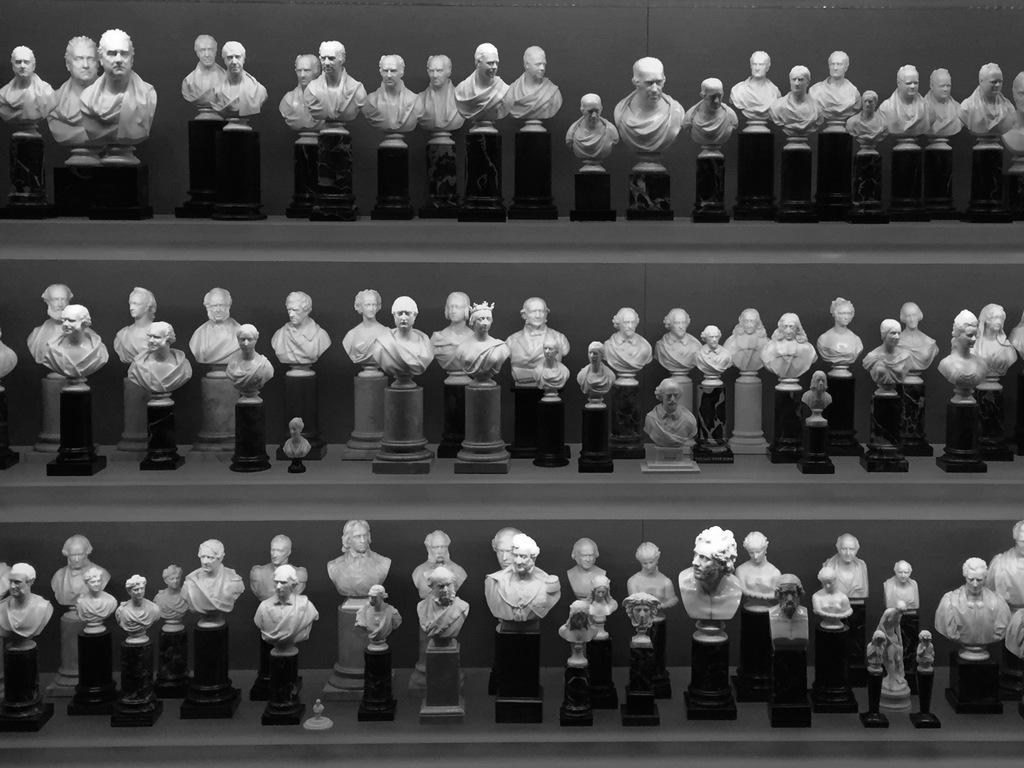What can be seen in the image? There is a display rack in the image. What is on the display rack? The display rack contains figurines. What type of tin is used to make the figurines in the image? There is no mention of tin or any specific material used to make the figurines in the image. The figurines are simply described as being on the display rack. 